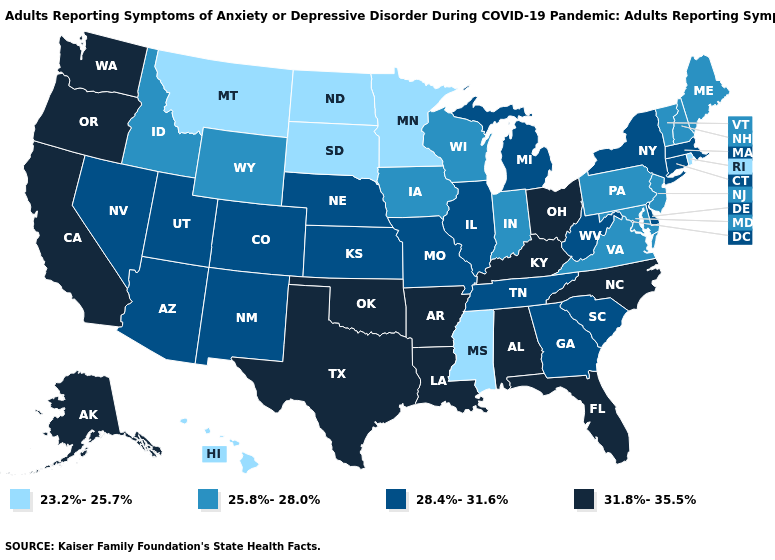What is the value of Minnesota?
Keep it brief. 23.2%-25.7%. Among the states that border Rhode Island , which have the lowest value?
Short answer required. Connecticut, Massachusetts. What is the lowest value in the MidWest?
Answer briefly. 23.2%-25.7%. How many symbols are there in the legend?
Keep it brief. 4. How many symbols are there in the legend?
Concise answer only. 4. What is the lowest value in states that border Tennessee?
Be succinct. 23.2%-25.7%. Which states have the lowest value in the USA?
Answer briefly. Hawaii, Minnesota, Mississippi, Montana, North Dakota, Rhode Island, South Dakota. Among the states that border Michigan , which have the highest value?
Concise answer only. Ohio. What is the lowest value in the Northeast?
Keep it brief. 23.2%-25.7%. Does New Jersey have the lowest value in the USA?
Write a very short answer. No. Does Vermont have a higher value than New Jersey?
Quick response, please. No. Which states hav the highest value in the MidWest?
Give a very brief answer. Ohio. Name the states that have a value in the range 25.8%-28.0%?
Quick response, please. Idaho, Indiana, Iowa, Maine, Maryland, New Hampshire, New Jersey, Pennsylvania, Vermont, Virginia, Wisconsin, Wyoming. Is the legend a continuous bar?
Write a very short answer. No. Does Kansas have a higher value than Idaho?
Keep it brief. Yes. 